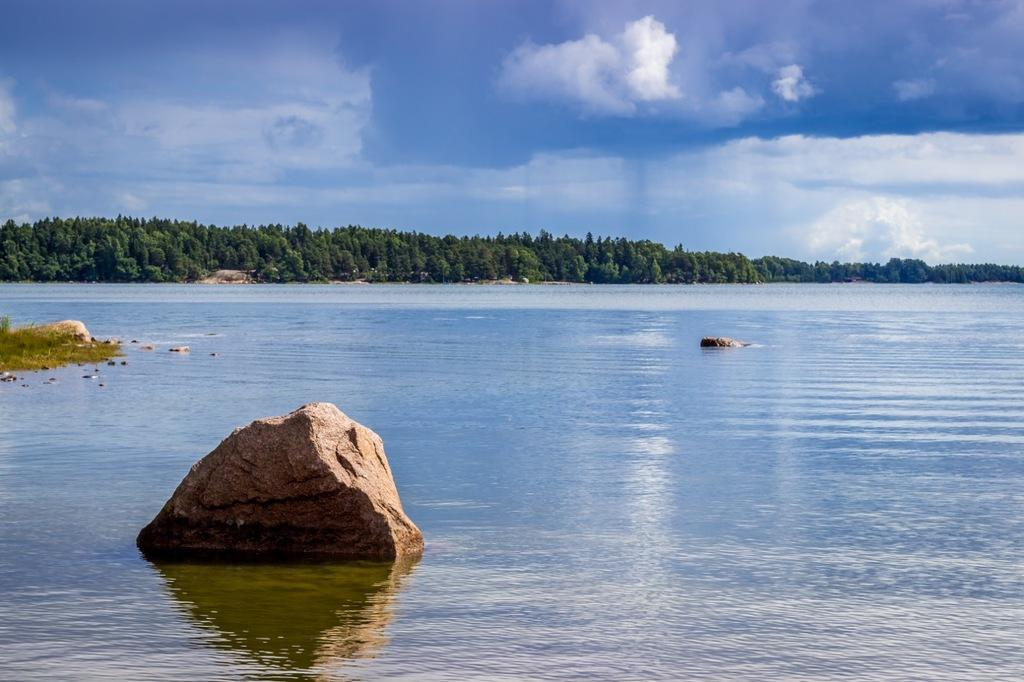What is the primary element in the image? There is water in the image. What other objects or features can be seen in the image? There are rocks in the image. What can be seen in the background of the image? There are trees in the background of the image. What is visible above the water and trees? The sky is visible in the image. What can be observed in the sky? Clouds are present in the sky. What type of patch is being used to create a rhythm in the image? There is no patch or rhythm present in the image; it features water, rocks, trees, and clouds. 